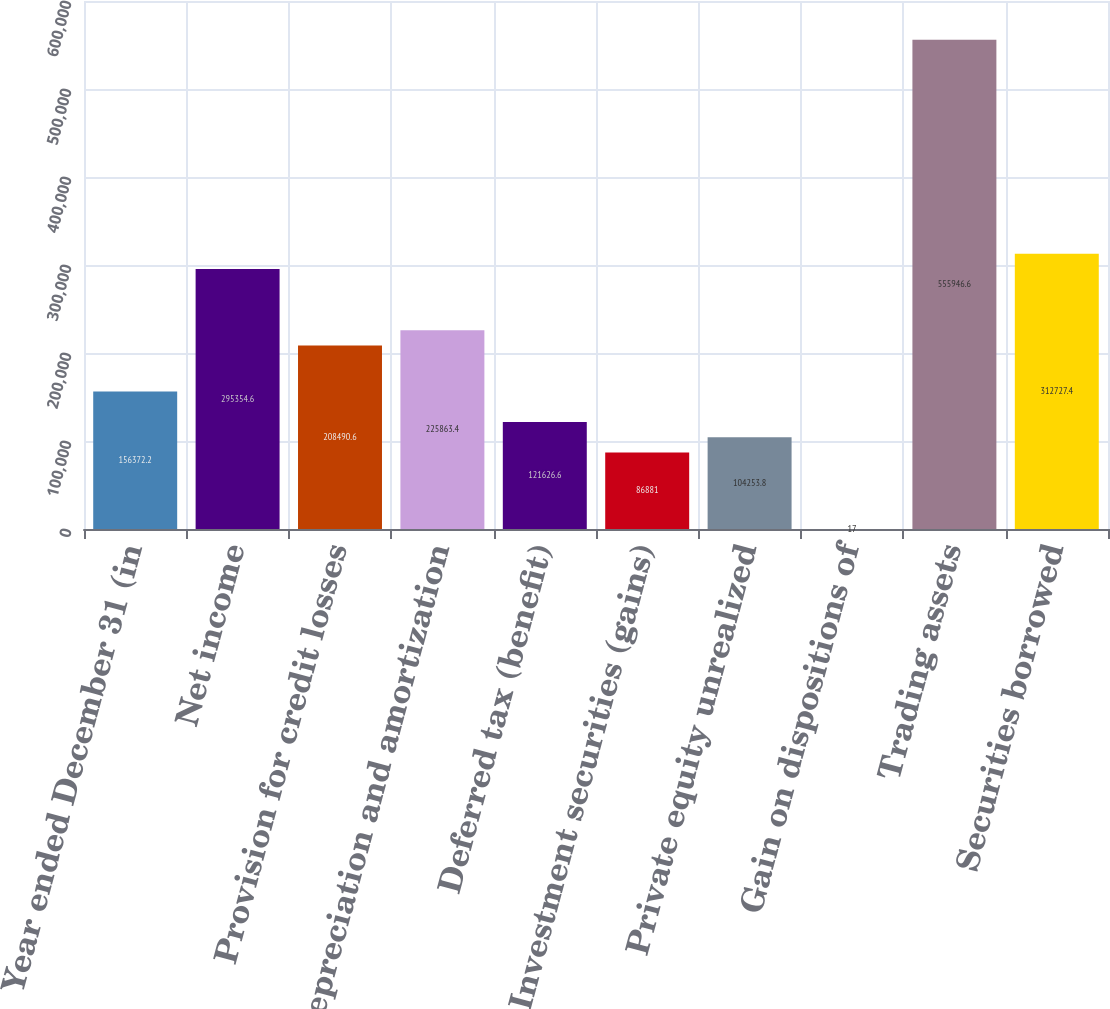<chart> <loc_0><loc_0><loc_500><loc_500><bar_chart><fcel>Year ended December 31 (in<fcel>Net income<fcel>Provision for credit losses<fcel>Depreciation and amortization<fcel>Deferred tax (benefit)<fcel>Investment securities (gains)<fcel>Private equity unrealized<fcel>Gain on dispositions of<fcel>Trading assets<fcel>Securities borrowed<nl><fcel>156372<fcel>295355<fcel>208491<fcel>225863<fcel>121627<fcel>86881<fcel>104254<fcel>17<fcel>555947<fcel>312727<nl></chart> 